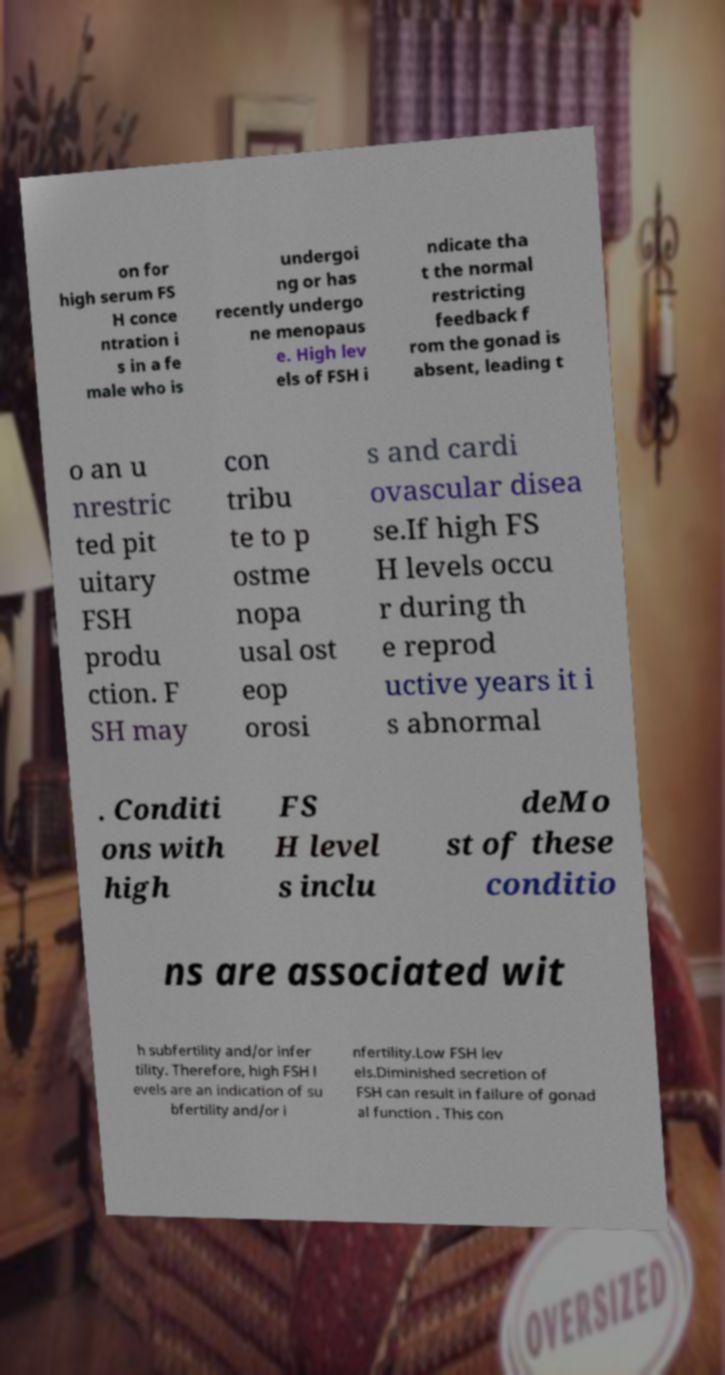I need the written content from this picture converted into text. Can you do that? on for high serum FS H conce ntration i s in a fe male who is undergoi ng or has recently undergo ne menopaus e. High lev els of FSH i ndicate tha t the normal restricting feedback f rom the gonad is absent, leading t o an u nrestric ted pit uitary FSH produ ction. F SH may con tribu te to p ostme nopa usal ost eop orosi s and cardi ovascular disea se.If high FS H levels occu r during th e reprod uctive years it i s abnormal . Conditi ons with high FS H level s inclu deMo st of these conditio ns are associated wit h subfertility and/or infer tility. Therefore, high FSH l evels are an indication of su bfertility and/or i nfertility.Low FSH lev els.Diminished secretion of FSH can result in failure of gonad al function . This con 